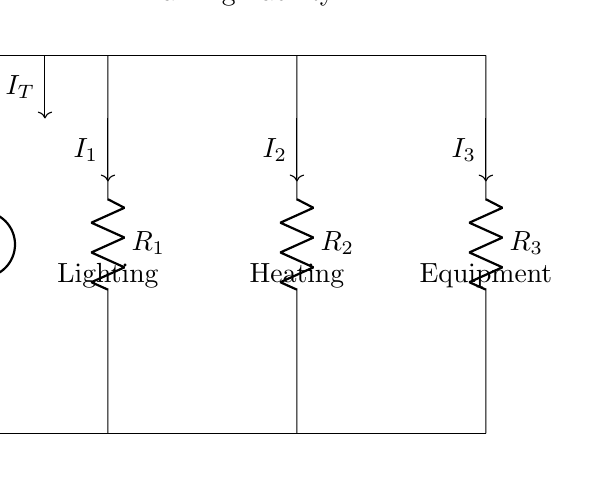What is the total current entering the circuit? The total current entering the circuit is denoted as I_T, which is indicated by the arrow pointing downwards from the voltage source.
Answer: I_T What components are shown in this circuit? The circuit diagram shows three resistors labeled R_1, R_2, and R_3, connected in parallel.
Answer: R_1, R_2, R_3 What are the functions of R_1, R_2, and R_3? R_1, R_2, and R_3 represent lighting, heating, and equipment respectively, as indicated by the labels below each component.
Answer: Lighting, Heating, Equipment How does the current divide at the junction? The current division occurs at the junction of the resistors; the current I_T splits into I_1, I_2, and I_3 according to the resistance values.
Answer: Proportionally What is the relationship between total current and individual currents? Each individual current (I_1, I_2, I_3) is a fraction of the total current (I_T), based on the total resistance in the circuit and the respective resistor values.
Answer: I_T = I_1 + I_2 + I_3 Which resistor has the highest current flowing through it? The current across each resistor can be analyzed; the one with the lowest resistance receives the highest current based on Ohm's Law. The shortest resistance leads to the highest current division.
Answer: R_1 or R_2 depending on their numerical values What effect does increasing R_3 have on I_3? Increasing R_3 would decrease the current I_3 flowing through it, as a higher resistance lowers the current in parallel circuits.
Answer: Decrease 